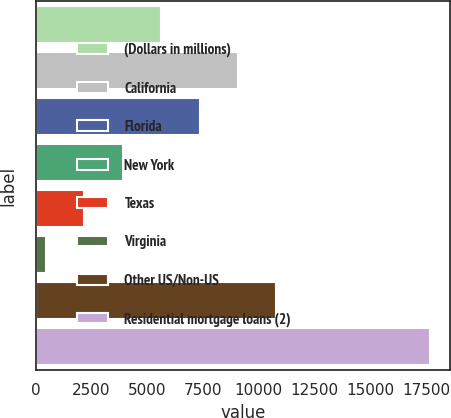Convert chart to OTSL. <chart><loc_0><loc_0><loc_500><loc_500><bar_chart><fcel>(Dollars in millions)<fcel>California<fcel>Florida<fcel>New York<fcel>Texas<fcel>Virginia<fcel>Other US/Non-US<fcel>Residential mortgage loans (2)<nl><fcel>5622.3<fcel>9070.5<fcel>7346.4<fcel>3898.2<fcel>2174.1<fcel>450<fcel>10794.6<fcel>17691<nl></chart> 